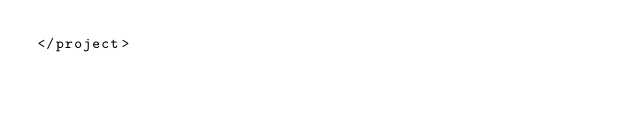Convert code to text. <code><loc_0><loc_0><loc_500><loc_500><_XML_></project>

</code> 